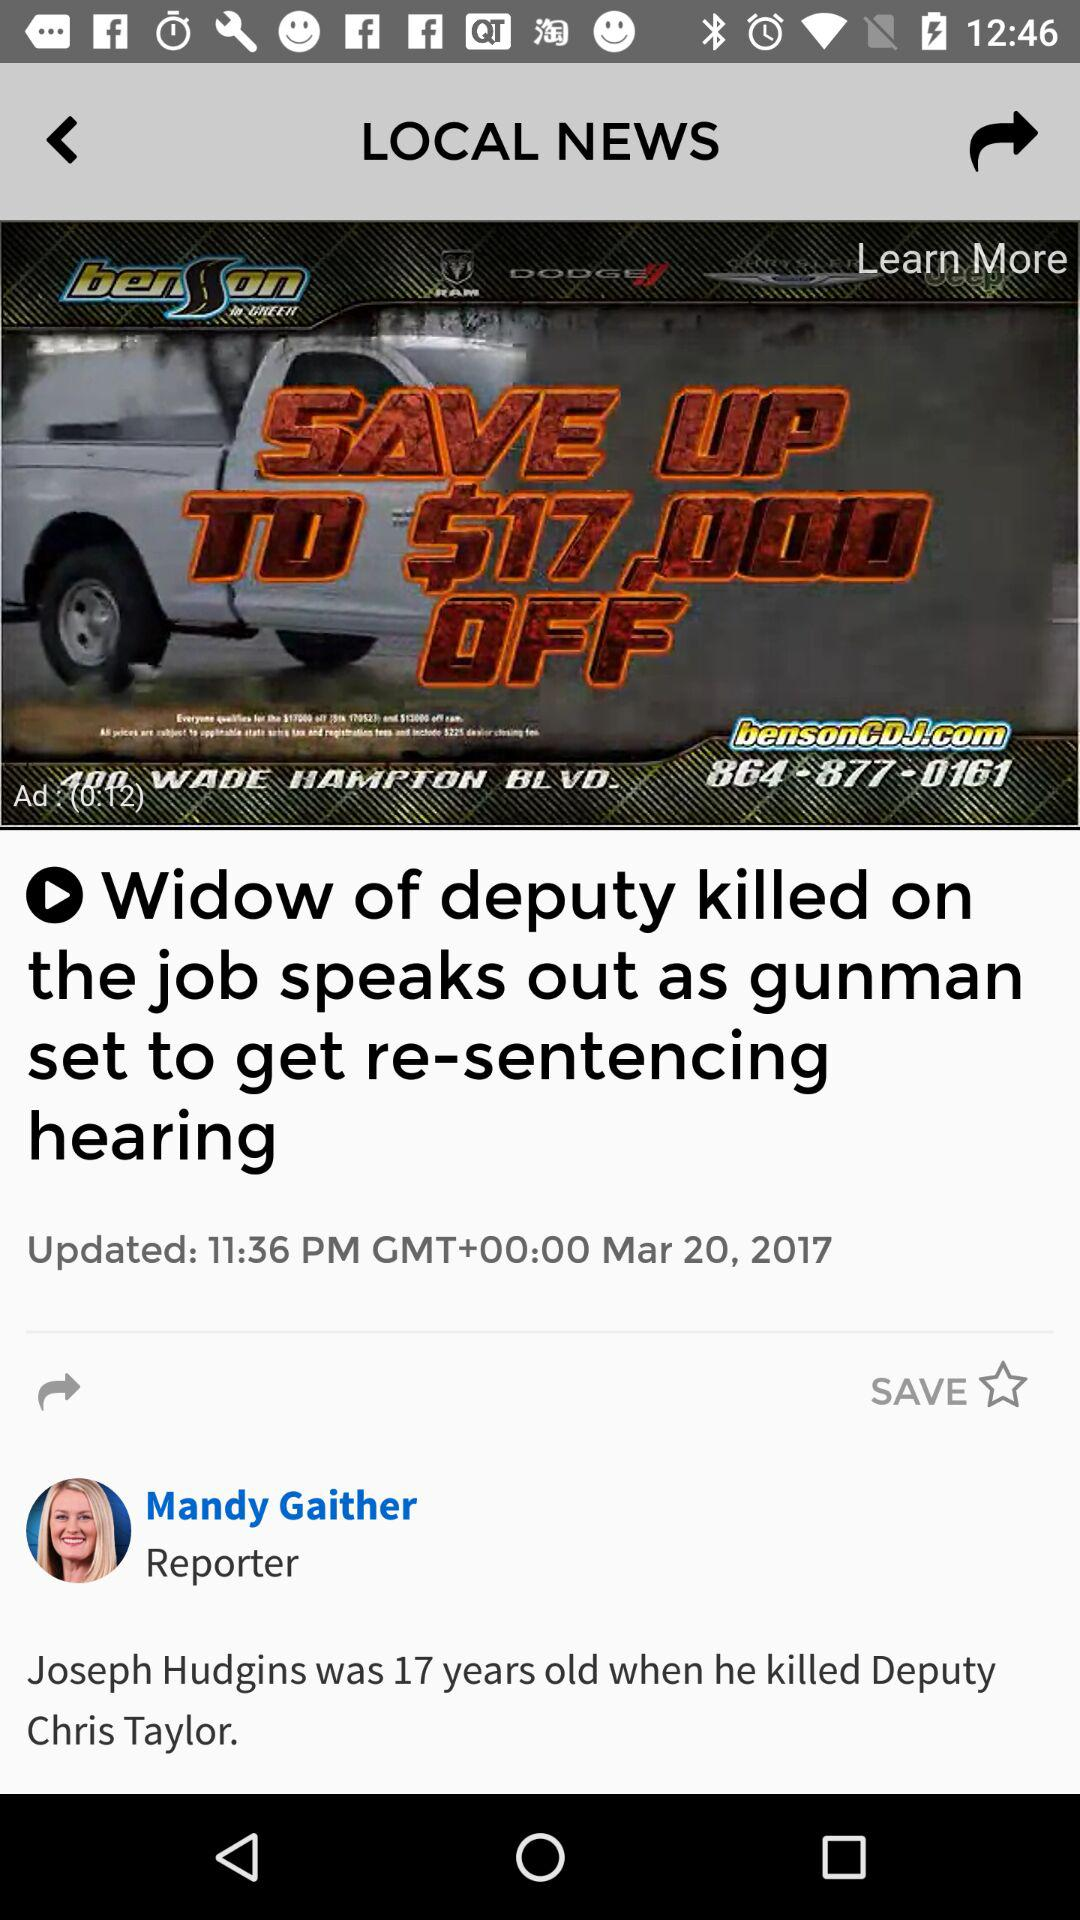What is the name of the reporter? The name of the reporter is Mandy Gaither. 